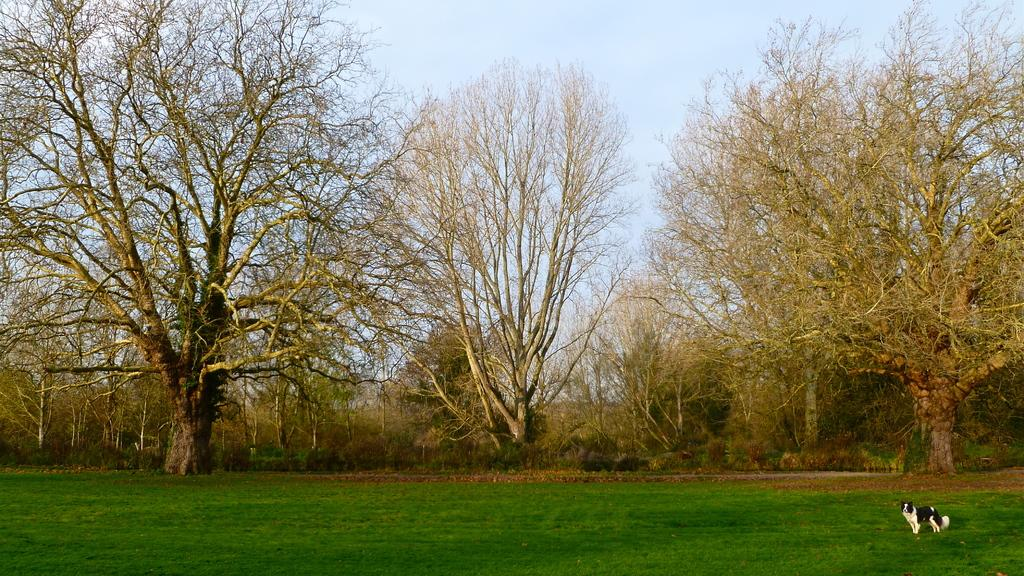What type of terrain is visible at the bottom of the image? There is grassland at the bottom side of the image. What animal can be seen on the right side of the image? There is a dog on the right side of the image. What type of vegetation is in the center of the image? There are trees in the center of the image. What type of wound can be seen on the dog in the image? There is no wound visible on the dog in the image. How many cows are present in the image? There are no cows present in the image. 